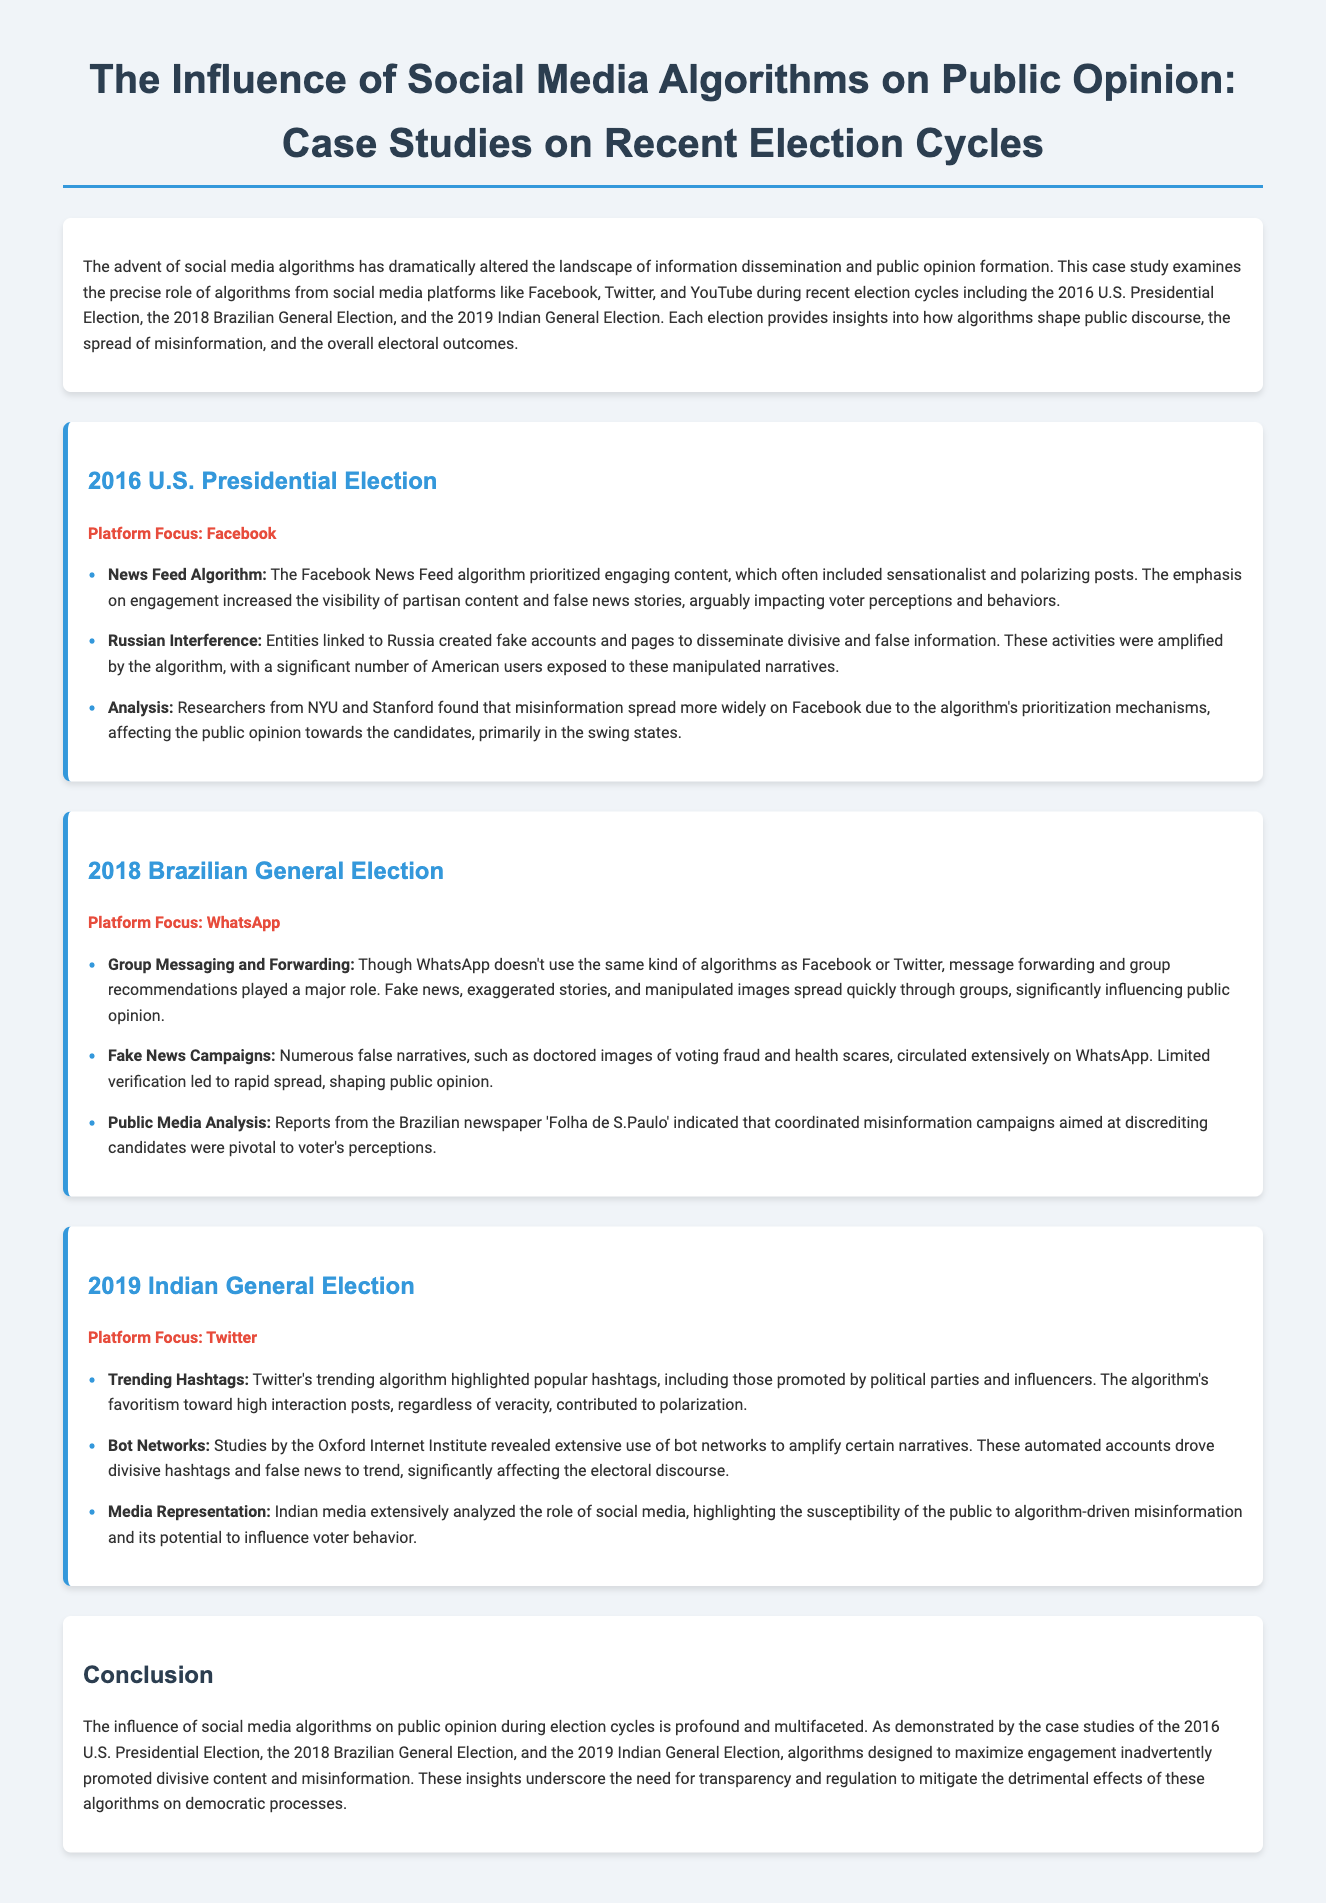what is the main focus of the case study? The case study focuses on the influence of social media algorithms on public opinion during election cycles.
Answer: influence of social media algorithms on public opinion which platform is highlighted in the 2016 U.S. Presidential Election case study? The platform highlighted in the case study is Facebook.
Answer: Facebook what type of content did the Facebook News Feed algorithm prioritize? The algorithm prioritized engaging content, often including sensationalist and polarizing posts.
Answer: engaging content how many elections are examined in the case study? The case study examines three elections: the 2016 U.S. Presidential Election, the 2018 Brazilian General Election, and the 2019 Indian General Election.
Answer: three what was a major influence on public opinion in the 2018 Brazilian General Election? Message forwarding and group recommendations on WhatsApp significantly influenced public opinion.
Answer: Message forwarding and group recommendations what findings did researchers from NYU and Stanford uncover regarding misinformation? They found that misinformation spread more widely on Facebook due to the algorithm's prioritization mechanisms.
Answer: misinformation spread more widely which algorithms were noted to mislead voters in the 2019 Indian General Election? Twitter's trending algorithm contributed to misleading voters due to its favoritism toward high interaction posts.
Answer: Twitter's trending algorithm what recommendation is suggested to mitigate the effects of algorithms on democratic processes? The document underscores the need for transparency and regulation.
Answer: transparency and regulation 